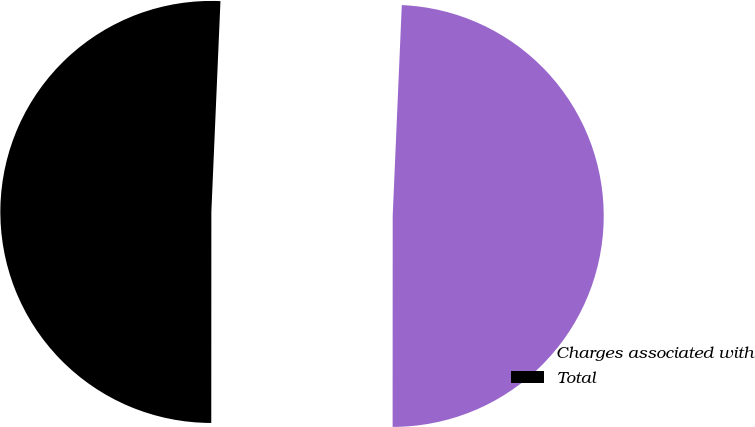<chart> <loc_0><loc_0><loc_500><loc_500><pie_chart><fcel>Charges associated with<fcel>Total<nl><fcel>49.32%<fcel>50.68%<nl></chart> 